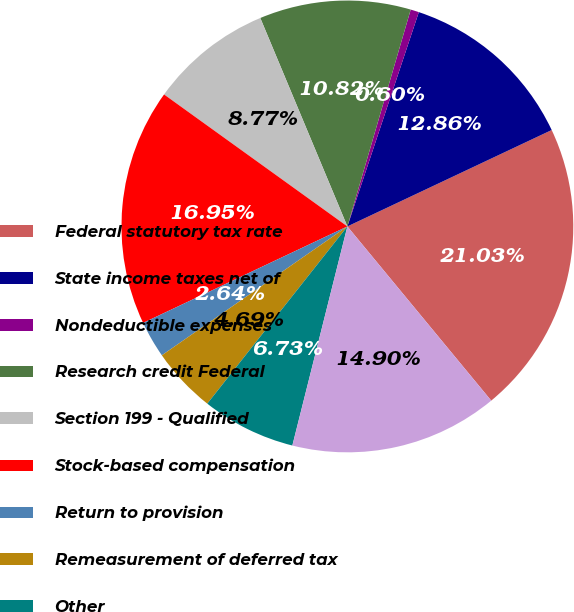<chart> <loc_0><loc_0><loc_500><loc_500><pie_chart><fcel>Federal statutory tax rate<fcel>State income taxes net of<fcel>Nondeductible expenses<fcel>Research credit Federal<fcel>Section 199 - Qualified<fcel>Stock-based compensation<fcel>Return to provision<fcel>Remeasurement of deferred tax<fcel>Other<fcel>Effective income tax rate<nl><fcel>21.03%<fcel>12.86%<fcel>0.6%<fcel>10.82%<fcel>8.77%<fcel>16.95%<fcel>2.64%<fcel>4.69%<fcel>6.73%<fcel>14.9%<nl></chart> 